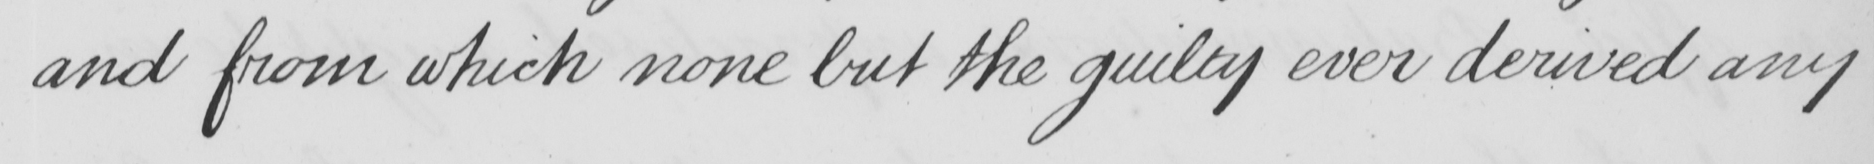What text is written in this handwritten line? and from which none but the guilty ever derived any 